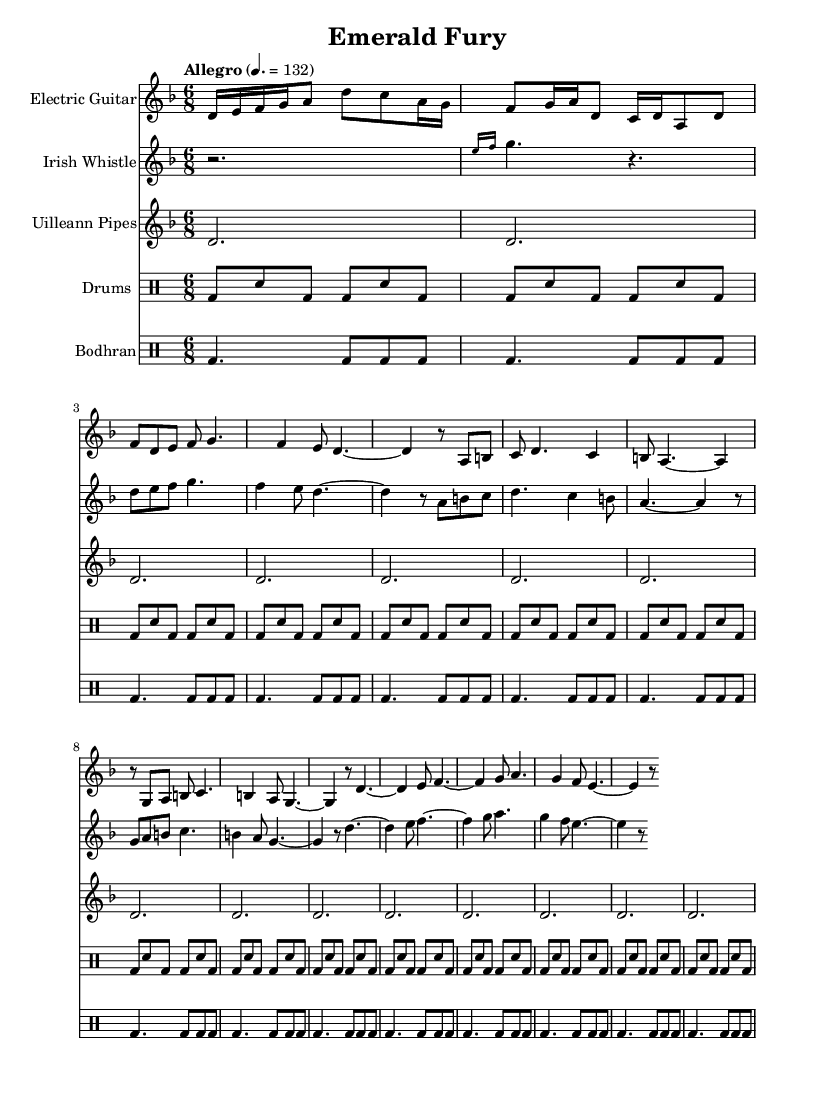What is the key signature of this music? The key signature is D minor, indicated by one flat (B flat) in the key signature section of the sheet music.
Answer: D minor What is the time signature of this music? The time signature is 6/8, represented at the beginning of the score where the note values are grouped in a way typical of compound time signatures.
Answer: 6/8 What is the tempo marking for this music? The tempo is marked as Allegro, specifically indicating a speed of quarter note equals 132 beats per minute, located at the start of the score.
Answer: Allegro How many measures are in the electric guitar part? The electric guitar part contains 12 measures, determined by counting the grouped sections separated by vertical bar lines in the staff.
Answer: 12 What type of drum is indicated first in the percussion section? The first drum indicated in the percussion section is the bass drum, as seen in the drumming part where bd represents the bass drum notation.
Answer: Bass drum Which instrument plays the longest sustained note in the score? The Uilleann Pipes play the longest sustained note, shown by the repeated whole notes in the part, specifically at the start of each measure.
Answer: Uilleann Pipes How many notes follow the grace note in the Irish Whistle part? In the Irish Whistle part, there are four notes that follow the grace note (g), which are d, e, f, g, as noted in the sequential part after the initial grace figure.
Answer: Four 